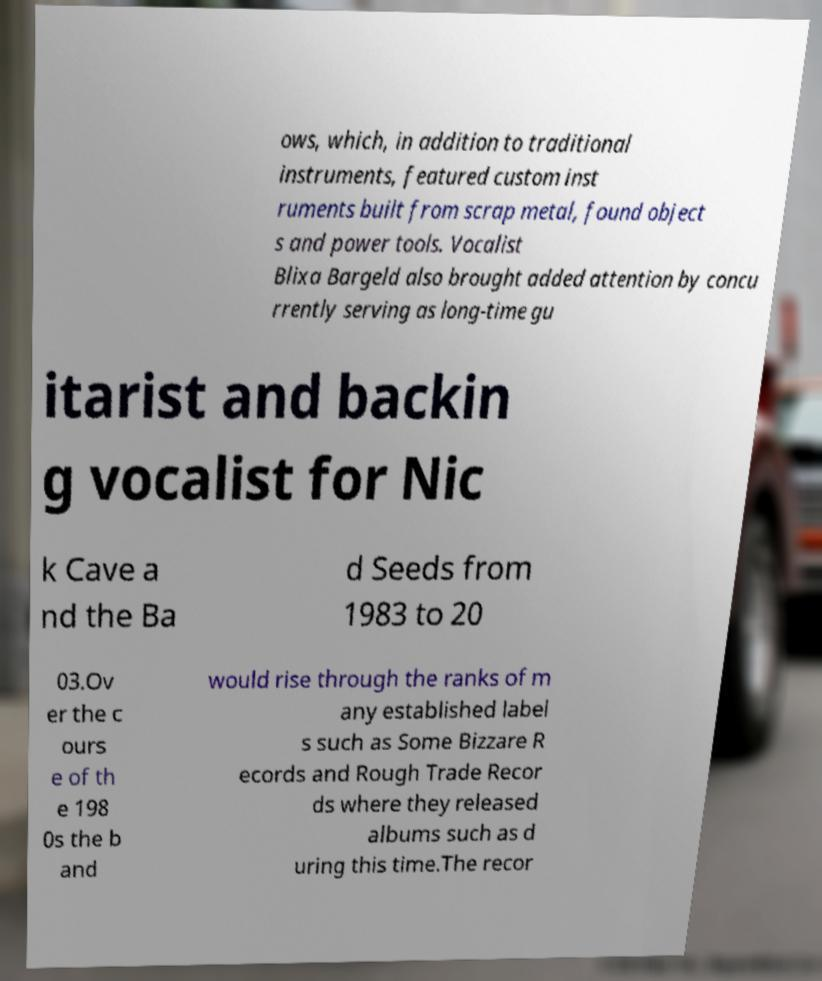Can you read and provide the text displayed in the image?This photo seems to have some interesting text. Can you extract and type it out for me? ows, which, in addition to traditional instruments, featured custom inst ruments built from scrap metal, found object s and power tools. Vocalist Blixa Bargeld also brought added attention by concu rrently serving as long-time gu itarist and backin g vocalist for Nic k Cave a nd the Ba d Seeds from 1983 to 20 03.Ov er the c ours e of th e 198 0s the b and would rise through the ranks of m any established label s such as Some Bizzare R ecords and Rough Trade Recor ds where they released albums such as d uring this time.The recor 